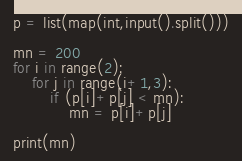<code> <loc_0><loc_0><loc_500><loc_500><_Python_>p = list(map(int,input().split()))

mn = 200
for i in range(2):
    for j in range(i+1,3):
        if (p[i]+p[j] < mn):
            mn = p[i]+p[j]

print(mn)


</code> 